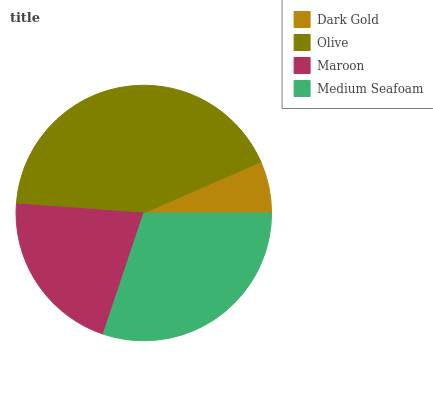Is Dark Gold the minimum?
Answer yes or no. Yes. Is Olive the maximum?
Answer yes or no. Yes. Is Maroon the minimum?
Answer yes or no. No. Is Maroon the maximum?
Answer yes or no. No. Is Olive greater than Maroon?
Answer yes or no. Yes. Is Maroon less than Olive?
Answer yes or no. Yes. Is Maroon greater than Olive?
Answer yes or no. No. Is Olive less than Maroon?
Answer yes or no. No. Is Medium Seafoam the high median?
Answer yes or no. Yes. Is Maroon the low median?
Answer yes or no. Yes. Is Olive the high median?
Answer yes or no. No. Is Medium Seafoam the low median?
Answer yes or no. No. 